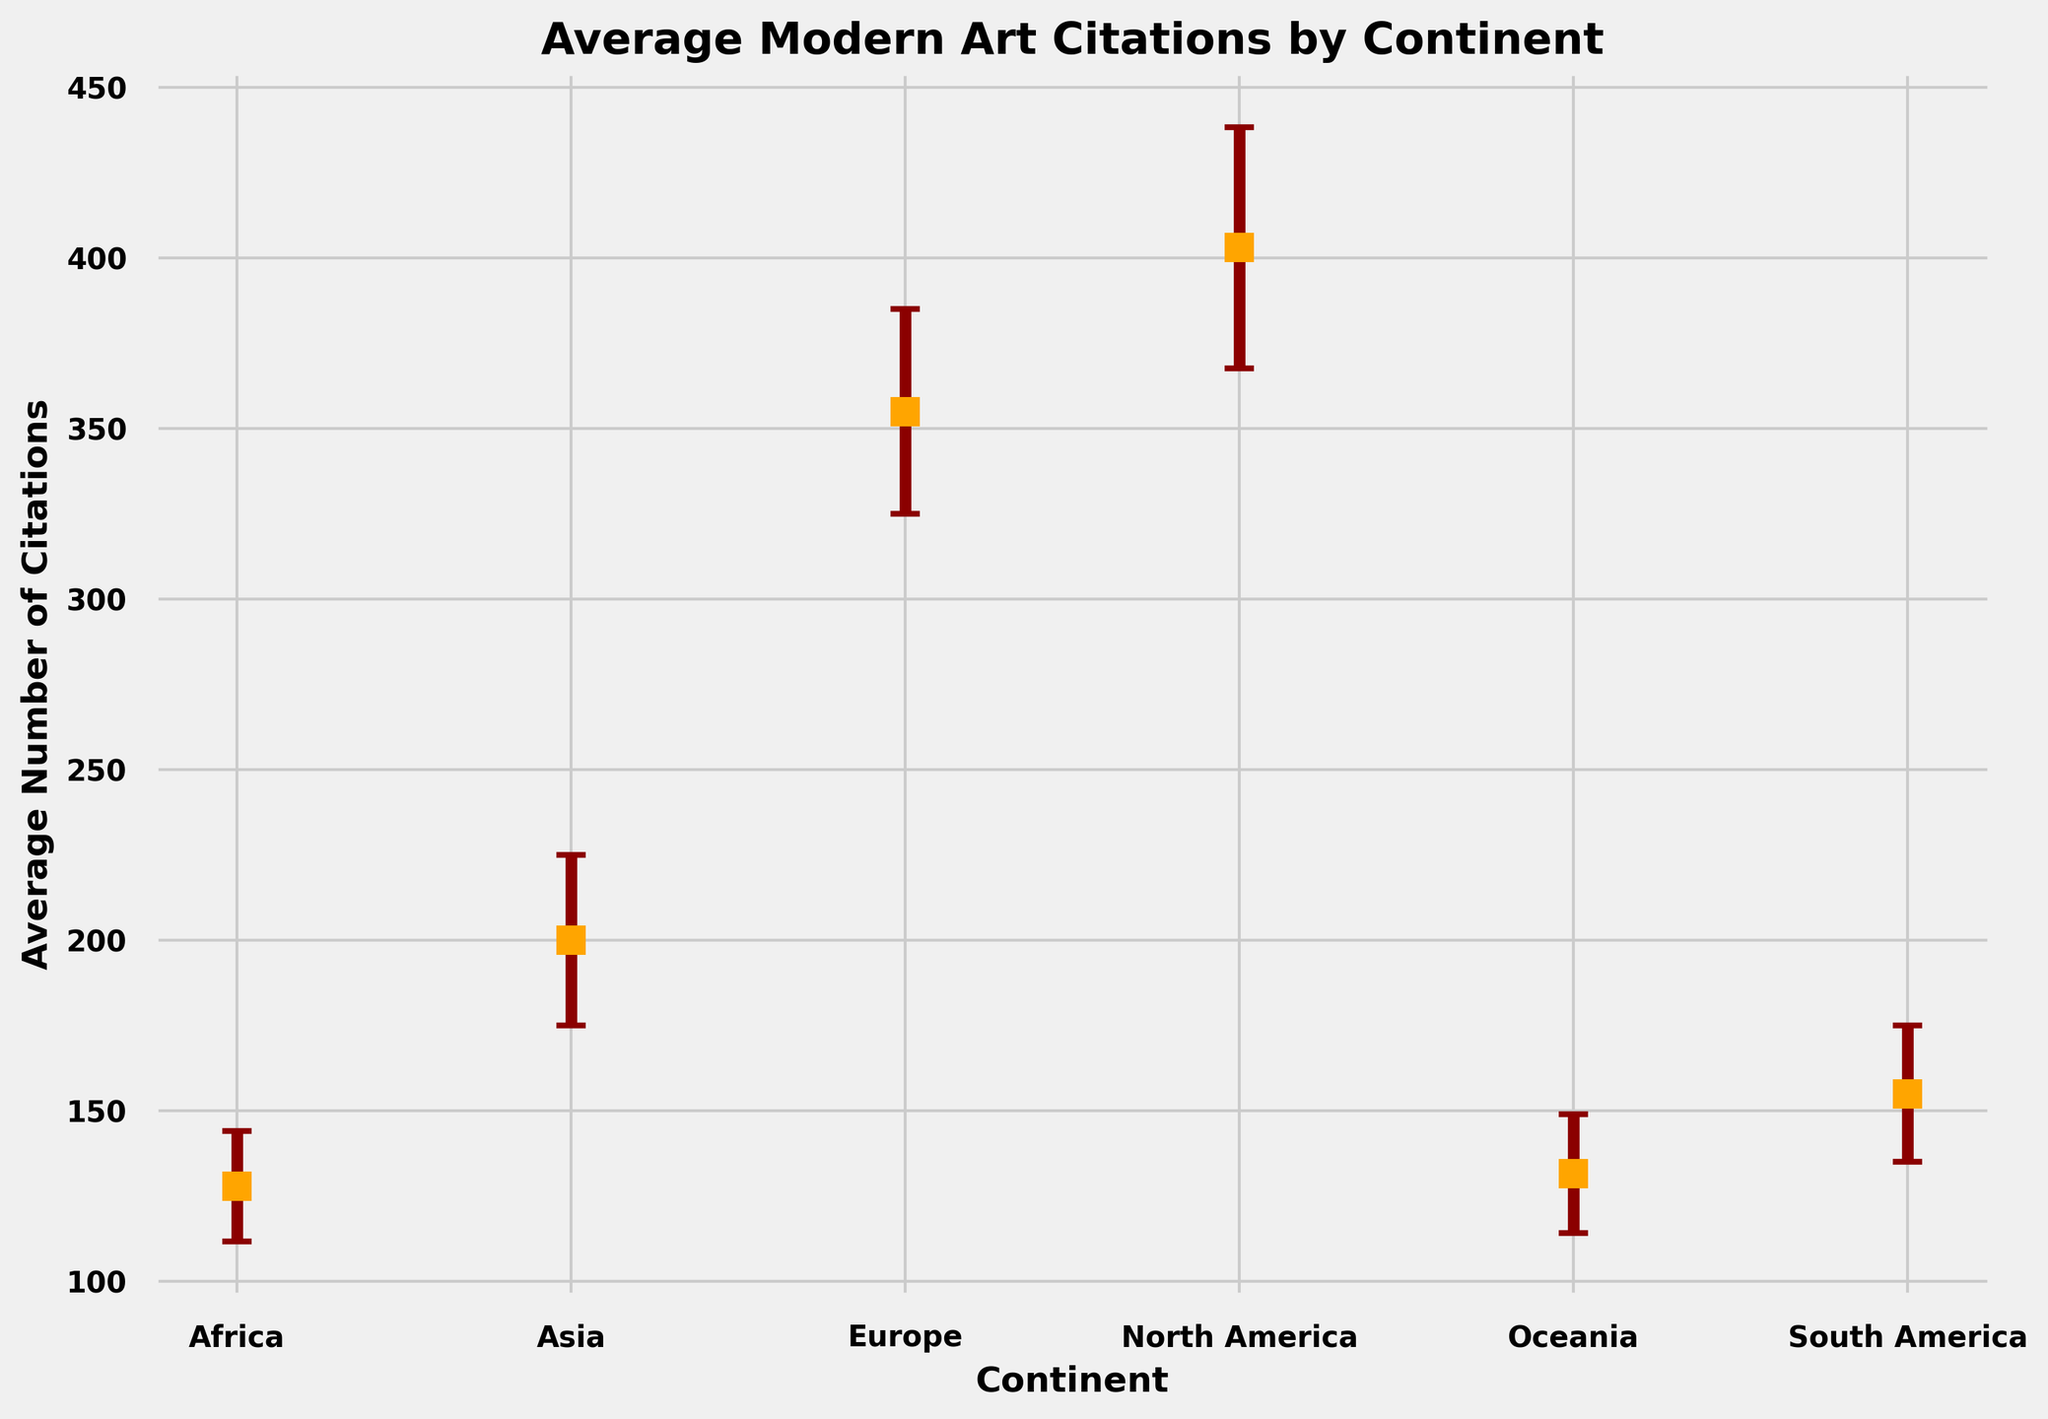What's the average number of citations for Asia and Africa? To find the average number of citations for Asia and Africa, look at the plot. Asia has 200 and Africa has 120 citations. Sum these values and then divide by 2: (200 + 120) / 2.
Answer: 160 Which continent has the highest average number of citations? The continent with the highest average number of citations can be identified by comparing the heights of the markers. North America has the highest marker indicating around 400 citations.
Answer: North America Between Europe and South America, which continent has a larger error margin? Look at the error bars for Europe and South America. Europe has larger error bars than South America.
Answer: Europe Which continent has the lowest average number of citations? The continent with the lowest average citations can be found by looking at the lowest markers on the plot. Africa has the lowest average number of citations, around 120.
Answer: Africa How does the average number of citations for Oceania compare to Europe? To compare average citations, look at the markers for both continents. Europe has a higher average number of citations than Oceania.
Answer: Europe has more What is the sum of the average number of citations for Europe and South America? To find this, add the average number of citations for Europe and South America from the plot: 350 and 150. Their sum is 500.
Answer: 500 Is the average number of citations for North America greater than that for South America plus Oceania? Look at the average citations for North America, around 400, and compare to the sum of South America (150) and Oceania (130). 400 is greater than the sum 280.
Answer: Yes Which continent has the smallest error margin represented? Identify the continents with the smallest error bars. Africa has the smallest error margin.
Answer: Africa Calculate the difference in the average number of citations between North America and Europe. Subtract the average citations for Europe from North America: 400 - 350. The difference is 50.
Answer: 50 What color represents the markers in the plot? Identify the color of the markers. The markers are orange in color.
Answer: Orange 